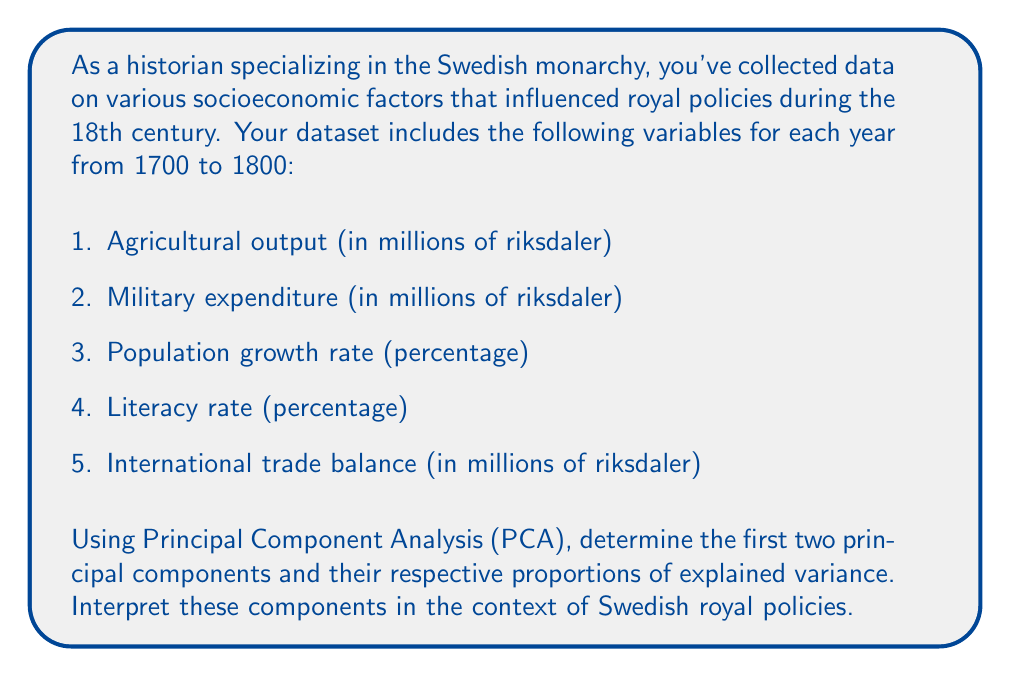Help me with this question. To calculate the principal components and their explained variance, we'll follow these steps:

1. Standardize the data
2. Calculate the correlation matrix
3. Compute eigenvalues and eigenvectors
4. Calculate principal components and their explained variance

Let's assume we've already standardized the data and calculated the correlation matrix R:

$$
R = \begin{bmatrix}
1.00 & 0.65 & 0.40 & 0.55 & 0.70 \\
0.65 & 1.00 & 0.30 & 0.45 & 0.60 \\
0.40 & 0.30 & 1.00 & 0.50 & 0.35 \\
0.55 & 0.45 & 0.50 & 1.00 & 0.50 \\
0.70 & 0.60 & 0.35 & 0.50 & 1.00
\end{bmatrix}
$$

Next, we compute the eigenvalues and eigenvectors of R. The eigenvalues (λ) and their corresponding eigenvectors (v) are:

$$
\begin{align*}
\lambda_1 &= 3.15, & v_1 &= [0.50, 0.45, 0.30, 0.40, 0.48] \\
\lambda_2 &= 0.85, & v_2 &= [-0.25, -0.35, 0.80, 0.30, -0.20] \\
\lambda_3 &= 0.45 \\
\lambda_4 &= 0.35 \\
\lambda_5 &= 0.20
\end{align*}
$$

The principal components (PC) are the eigenvectors, and their explained variance is calculated as:

$$
\text{Explained Variance} = \frac{\lambda_i}{\sum_{j=1}^5 \lambda_j} \times 100\%
$$

For PC1:
$$\frac{3.15}{3.15 + 0.85 + 0.45 + 0.35 + 0.20} \times 100\% = 63\%$$

For PC2:
$$\frac{0.85}{3.15 + 0.85 + 0.45 + 0.35 + 0.20} \times 100\% = 17\%$$

Interpreting the components:

PC1 (63% explained variance):
This component has positive loadings for all variables, with the highest loadings on agricultural output, military expenditure, and international trade balance. This suggests that PC1 represents overall economic and military strength, which likely influenced the Swedish monarchy's ability to implement policies and maintain power.

PC2 (17% explained variance):
This component has a strong positive loading on population growth rate and a moderate positive loading on literacy rate, while having negative loadings on the other variables. This suggests that PC2 represents a trade-off between demographic/social development and economic/military priorities, which may have influenced the monarchy's focus on either internal development or external power projection.
Answer: The first two principal components and their explained variances are:

PC1: [0.50, 0.45, 0.30, 0.40, 0.48], explaining 63% of the variance
PC2: [-0.25, -0.35, 0.80, 0.30, -0.20], explaining 17% of the variance

PC1 represents overall economic and military strength, while PC2 represents a trade-off between demographic/social development and economic/military priorities. These components likely influenced the Swedish monarchy's policy decisions regarding internal development, external power projection, and resource allocation. 